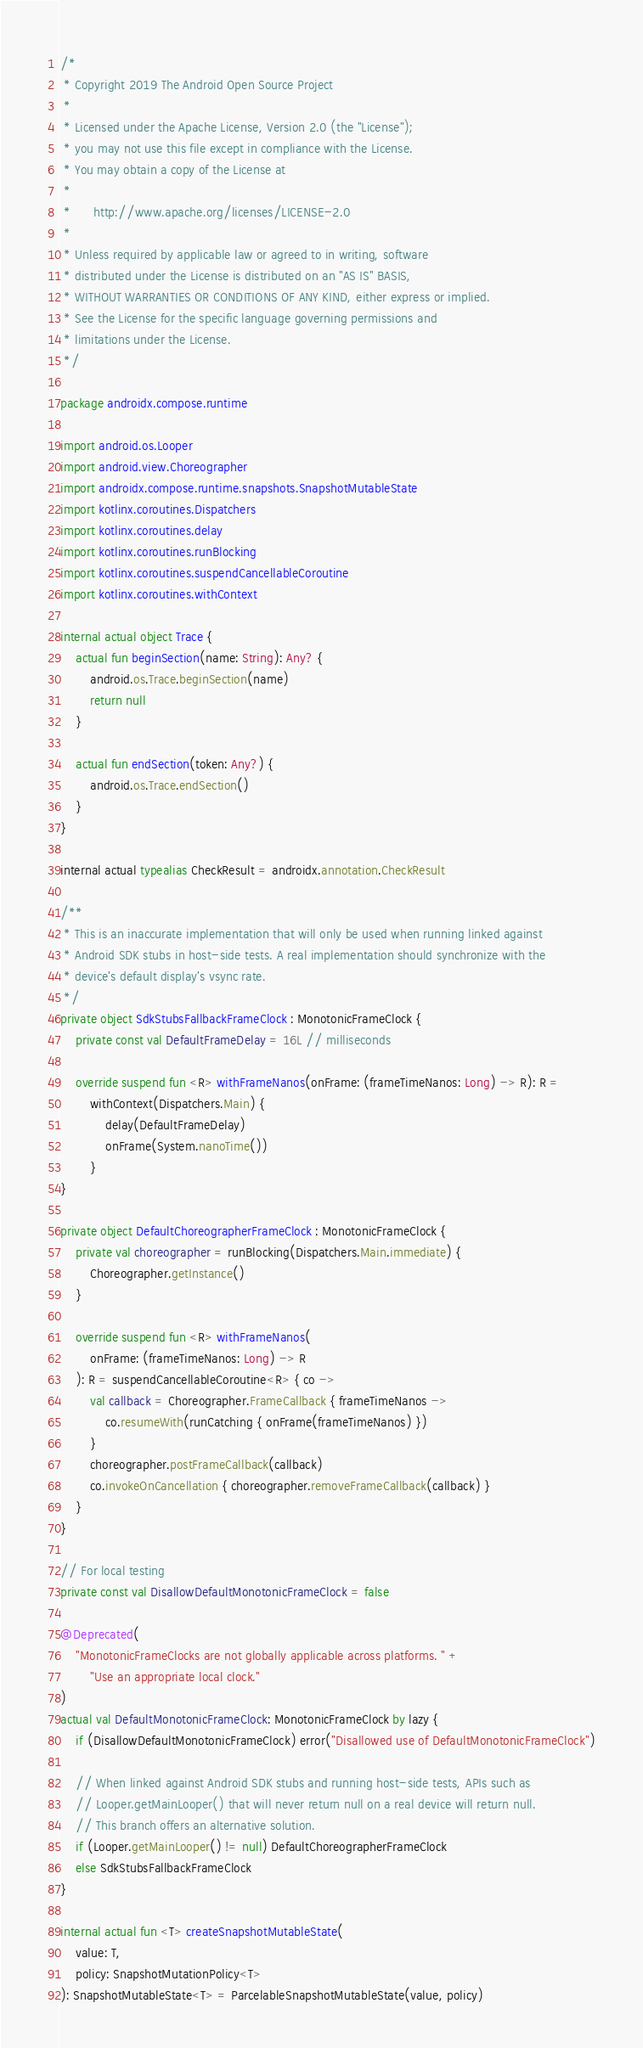<code> <loc_0><loc_0><loc_500><loc_500><_Kotlin_>/*
 * Copyright 2019 The Android Open Source Project
 *
 * Licensed under the Apache License, Version 2.0 (the "License");
 * you may not use this file except in compliance with the License.
 * You may obtain a copy of the License at
 *
 *      http://www.apache.org/licenses/LICENSE-2.0
 *
 * Unless required by applicable law or agreed to in writing, software
 * distributed under the License is distributed on an "AS IS" BASIS,
 * WITHOUT WARRANTIES OR CONDITIONS OF ANY KIND, either express or implied.
 * See the License for the specific language governing permissions and
 * limitations under the License.
 */

package androidx.compose.runtime

import android.os.Looper
import android.view.Choreographer
import androidx.compose.runtime.snapshots.SnapshotMutableState
import kotlinx.coroutines.Dispatchers
import kotlinx.coroutines.delay
import kotlinx.coroutines.runBlocking
import kotlinx.coroutines.suspendCancellableCoroutine
import kotlinx.coroutines.withContext

internal actual object Trace {
    actual fun beginSection(name: String): Any? {
        android.os.Trace.beginSection(name)
        return null
    }

    actual fun endSection(token: Any?) {
        android.os.Trace.endSection()
    }
}

internal actual typealias CheckResult = androidx.annotation.CheckResult

/**
 * This is an inaccurate implementation that will only be used when running linked against
 * Android SDK stubs in host-side tests. A real implementation should synchronize with the
 * device's default display's vsync rate.
 */
private object SdkStubsFallbackFrameClock : MonotonicFrameClock {
    private const val DefaultFrameDelay = 16L // milliseconds

    override suspend fun <R> withFrameNanos(onFrame: (frameTimeNanos: Long) -> R): R =
        withContext(Dispatchers.Main) {
            delay(DefaultFrameDelay)
            onFrame(System.nanoTime())
        }
}

private object DefaultChoreographerFrameClock : MonotonicFrameClock {
    private val choreographer = runBlocking(Dispatchers.Main.immediate) {
        Choreographer.getInstance()
    }

    override suspend fun <R> withFrameNanos(
        onFrame: (frameTimeNanos: Long) -> R
    ): R = suspendCancellableCoroutine<R> { co ->
        val callback = Choreographer.FrameCallback { frameTimeNanos ->
            co.resumeWith(runCatching { onFrame(frameTimeNanos) })
        }
        choreographer.postFrameCallback(callback)
        co.invokeOnCancellation { choreographer.removeFrameCallback(callback) }
    }
}

// For local testing
private const val DisallowDefaultMonotonicFrameClock = false

@Deprecated(
    "MonotonicFrameClocks are not globally applicable across platforms. " +
        "Use an appropriate local clock."
)
actual val DefaultMonotonicFrameClock: MonotonicFrameClock by lazy {
    if (DisallowDefaultMonotonicFrameClock) error("Disallowed use of DefaultMonotonicFrameClock")

    // When linked against Android SDK stubs and running host-side tests, APIs such as
    // Looper.getMainLooper() that will never return null on a real device will return null.
    // This branch offers an alternative solution.
    if (Looper.getMainLooper() != null) DefaultChoreographerFrameClock
    else SdkStubsFallbackFrameClock
}

internal actual fun <T> createSnapshotMutableState(
    value: T,
    policy: SnapshotMutationPolicy<T>
): SnapshotMutableState<T> = ParcelableSnapshotMutableState(value, policy)
</code> 